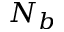<formula> <loc_0><loc_0><loc_500><loc_500>N _ { b }</formula> 